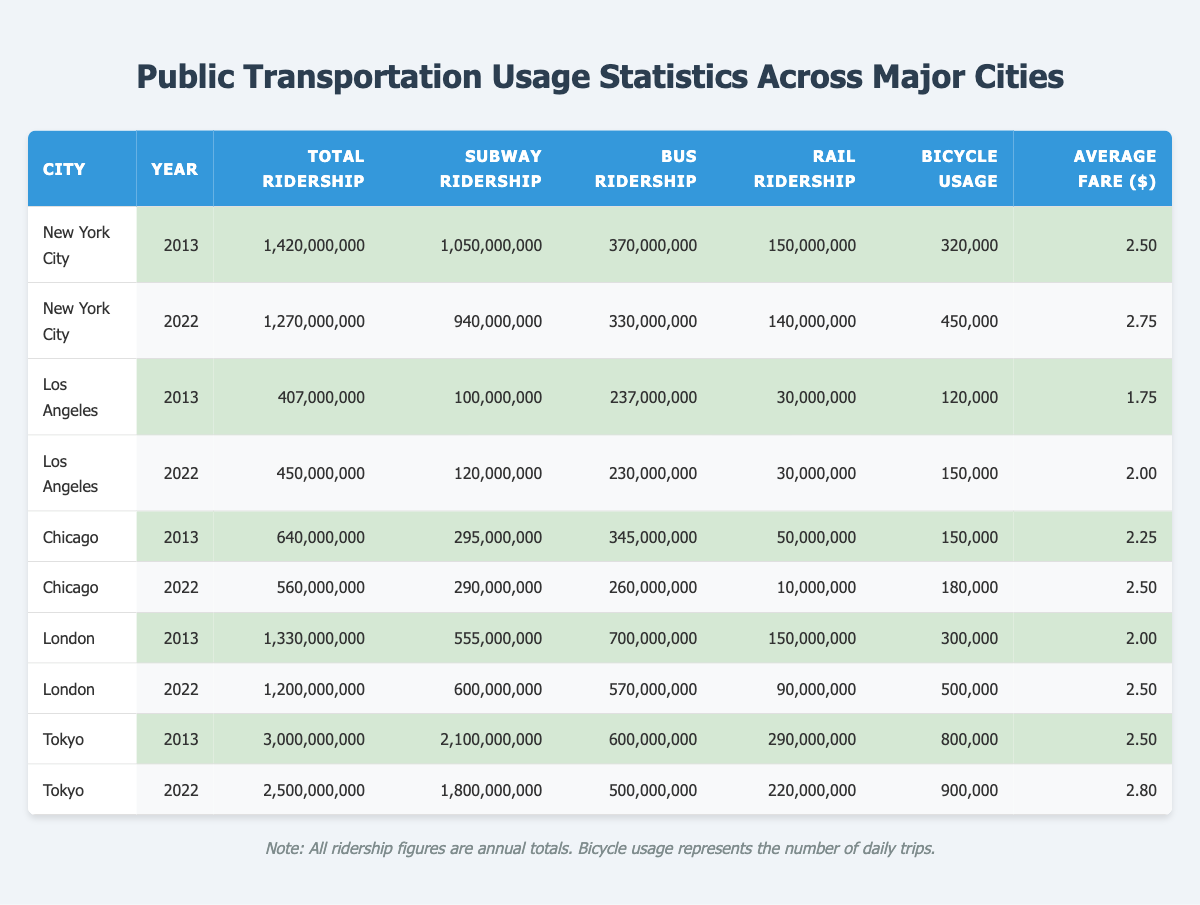What was the total ridership in New York City in 2013? The table shows the total ridership for New York City in 2013, which is listed as 1,420,000,000.
Answer: 1,420,000,000 How many riders used buses in Los Angeles in 2022? According to the table, the bus ridership for Los Angeles in 2022 is recorded as 230,000,000.
Answer: 230,000,000 What city had the highest subway ridership in 2013? Looking at the subway ridership for 2013, Tokyo has the highest figure at 2,100,000,000.
Answer: Tokyo What is the difference in total ridership between Chicago in 2013 and 2022? Chicago's total ridership in 2013 is 640,000,000 and in 2022 it is 560,000,000. The difference is 640,000,000 - 560,000,000 = 80,000,000.
Answer: 80,000,000 Which city had more bicycle usage in 2022, Los Angeles or Chicago? In 2022, Los Angeles had 150,000 bicycle usages and Chicago had 180,000. Since 180,000 > 150,000, Chicago had more bicycle usage.
Answer: Chicago What is the average fare for public transportation in all cities in 2022? The average fare for Los Angeles is 2.00, Chicago is 2.50, New York City is 2.75, London is 2.50, and Tokyo is 2.80. Total fare = 2.00 + 2.50 + 2.75 + 2.50 + 2.80 = 12.55, and there are 5 cities, so the average fare is 12.55 / 5 = 2.51.
Answer: 2.51 True or False: New York City's total ridership decreased from 2013 to 2022. In 2013, New York City's total ridership was 1,420,000,000, and in 2022 it was 1,270,000,000. Since 1,270,000,000 < 1,420,000,000, this statement is true.
Answer: True Which city's bus ridership increased between 2013 and 2022? The table shows that Los Angeles had bus ridership of 237,000,000 in 2013 and 230,000,000 in 2022. Chicago decreased from 345,000,000 to 260,000,000, London decreased from 700,000,000 to 570,000,000, but New York City had a slight decrease from 370,000,000 to 330,000,000. None of them increased.
Answer: None What was the total ridership for Tokyo in 2022? The total ridership for Tokyo in 2022, as shown in the table, is 2,500,000,000.
Answer: 2,500,000,000 How many more subway riders did New York City have than Los Angeles in 2022? In 2022, New York City's subway ridership was 940,000,000, while Los Angeles had 120,000,000. The difference is 940,000,000 - 120,000,000 = 820,000,000.
Answer: 820,000,000 